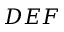<formula> <loc_0><loc_0><loc_500><loc_500>D E F</formula> 